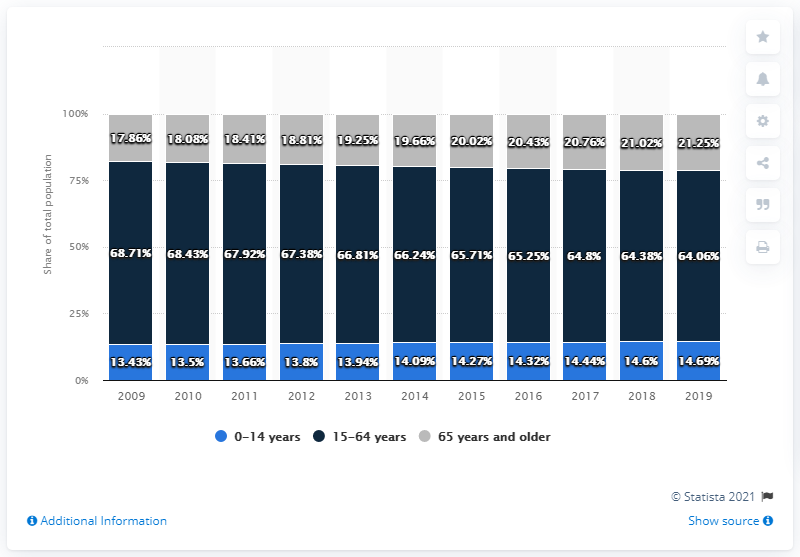List a handful of essential elements in this visual. In 2017, the percentage of the population aged 15 to 64 was 44.04%, while the percentage of the population aged 65 and older was 6.47%. In the year 2011, the percentage of the population aged 0-14 years was 13.66%. 